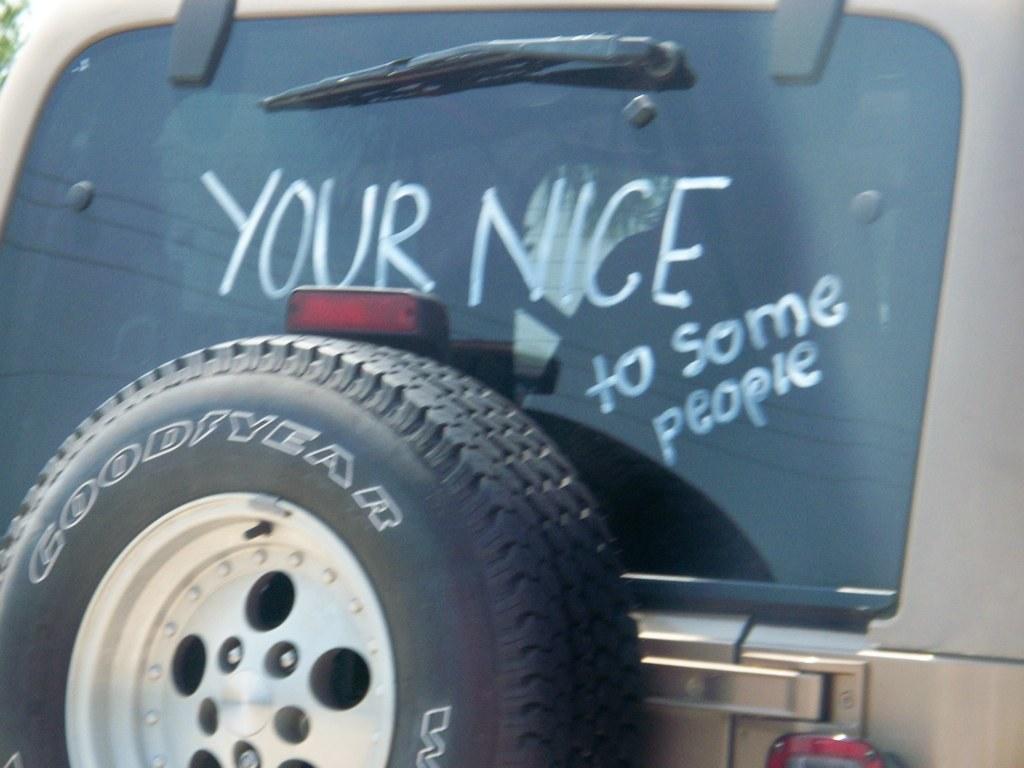Please provide a concise description of this image. In this image I can see a back window of vehicle , on which I can see text and there is a Tyre attached to the window. 